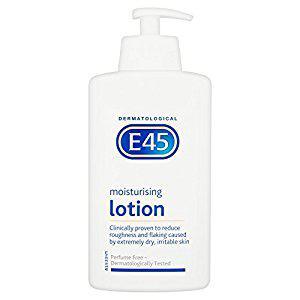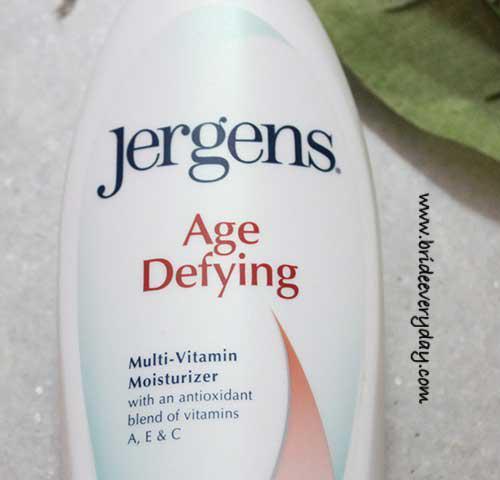The first image is the image on the left, the second image is the image on the right. Analyze the images presented: Is the assertion "Only one white bottle is squat and rectangular shaped with rounded edges and a pump top." valid? Answer yes or no. Yes. The first image is the image on the left, the second image is the image on the right. Assess this claim about the two images: "Left image shows a product with a pump-top dispenser.". Correct or not? Answer yes or no. Yes. 